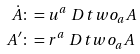<formula> <loc_0><loc_0><loc_500><loc_500>\dot { A } & \colon = u ^ { a } \ D t w o _ { a } A \\ A ^ { \prime } & \colon = r ^ { a } \ D t w o _ { a } A</formula> 